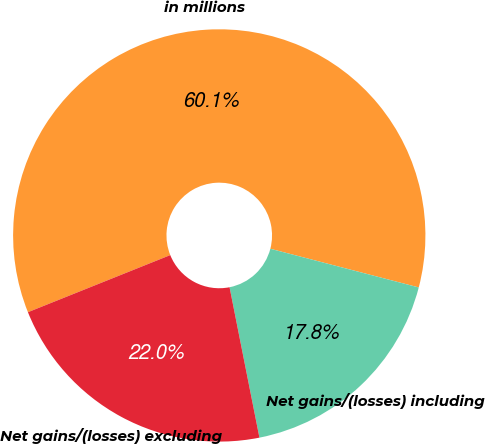<chart> <loc_0><loc_0><loc_500><loc_500><pie_chart><fcel>in millions<fcel>Net gains/(losses) including<fcel>Net gains/(losses) excluding<nl><fcel>60.13%<fcel>17.82%<fcel>22.05%<nl></chart> 